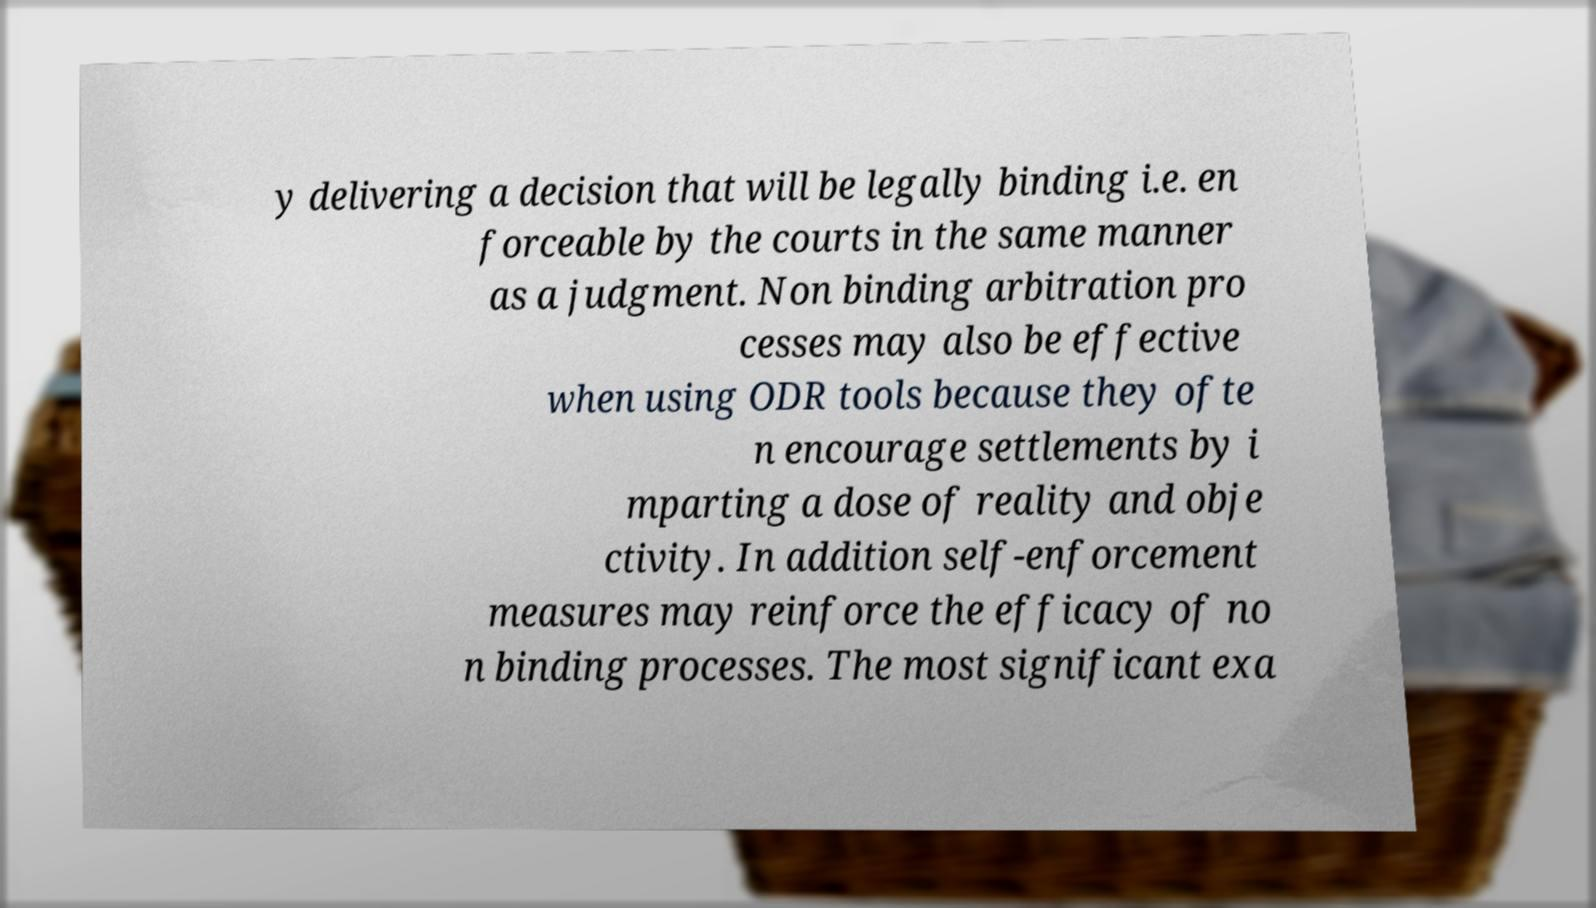Could you extract and type out the text from this image? y delivering a decision that will be legally binding i.e. en forceable by the courts in the same manner as a judgment. Non binding arbitration pro cesses may also be effective when using ODR tools because they ofte n encourage settlements by i mparting a dose of reality and obje ctivity. In addition self-enforcement measures may reinforce the efficacy of no n binding processes. The most significant exa 